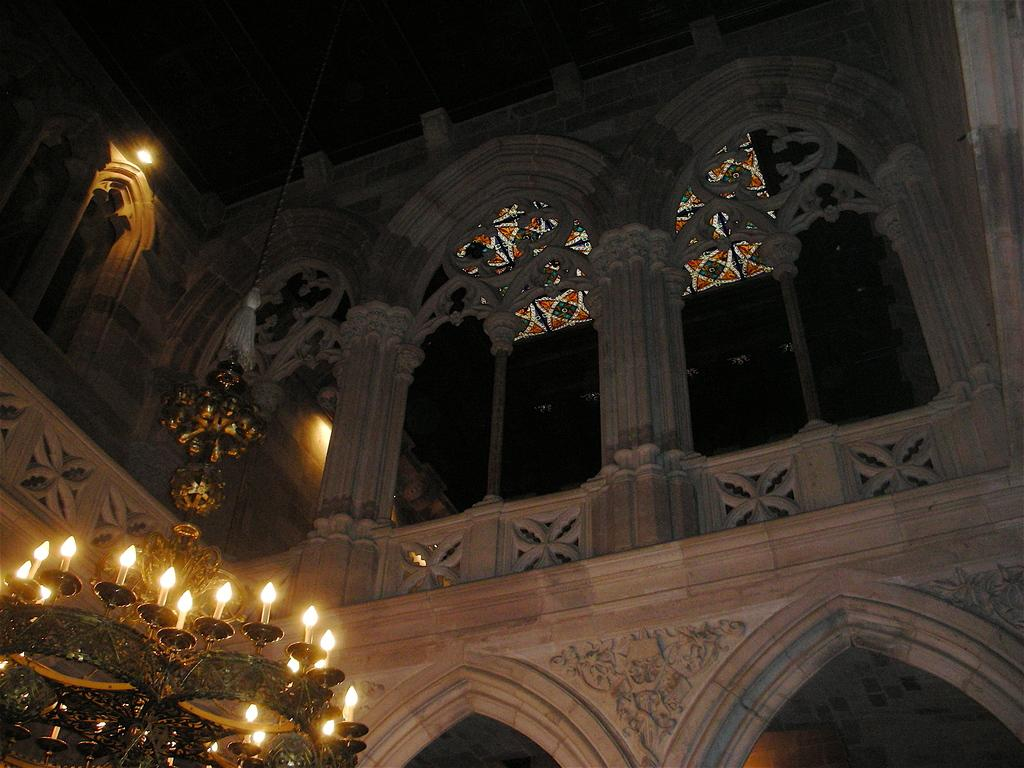What is the main subject of the image? The main subject of the image is a building under construction. What type of design can be seen in the construction of the building? There is an arch design construction in the building. What decorative element is visible on the roof of the building? A chandelier is visible on the roof of the building. How many rings are being used to support the tramp in the image? There is no tramp or rings present in the image; it shows a building under construction with an arch design and a chandelier on the roof. --- Facts: 1. There is a person sitting on a bench in the image. 2. The person is reading a book. 3. There is a tree behind the bench. 4. The sky is visible in the image. Absurd Topics: parrot, skateboard, volcano Conversation: What is the person in the image doing? The person in the image is sitting on a bench and reading a book. What is located behind the bench in the image? There is a tree behind the bench in the image. What can be seen in the sky in the image? The sky is visible in the image. Reasoning: Let's think step by step in order to produce the conversation. We start by identifying the main subject of the image, which is the person sitting on the bench. Then, we describe the activity the person is engaged in, which is reading a book. Next, we mention the object located behind the bench, which is a tree. Finally, we acknowledge the presence of the sky in the image. Each question is designed to elicit a specific detail about the image that is known from the provided facts. Absurd Question/Answer: Can you tell me how many parrots are sitting on the skateboard in the image? There are no parrots or skateboards present in the image; it shows a person sitting on a bench reading a book with a tree behind the bench and the sky visible. 